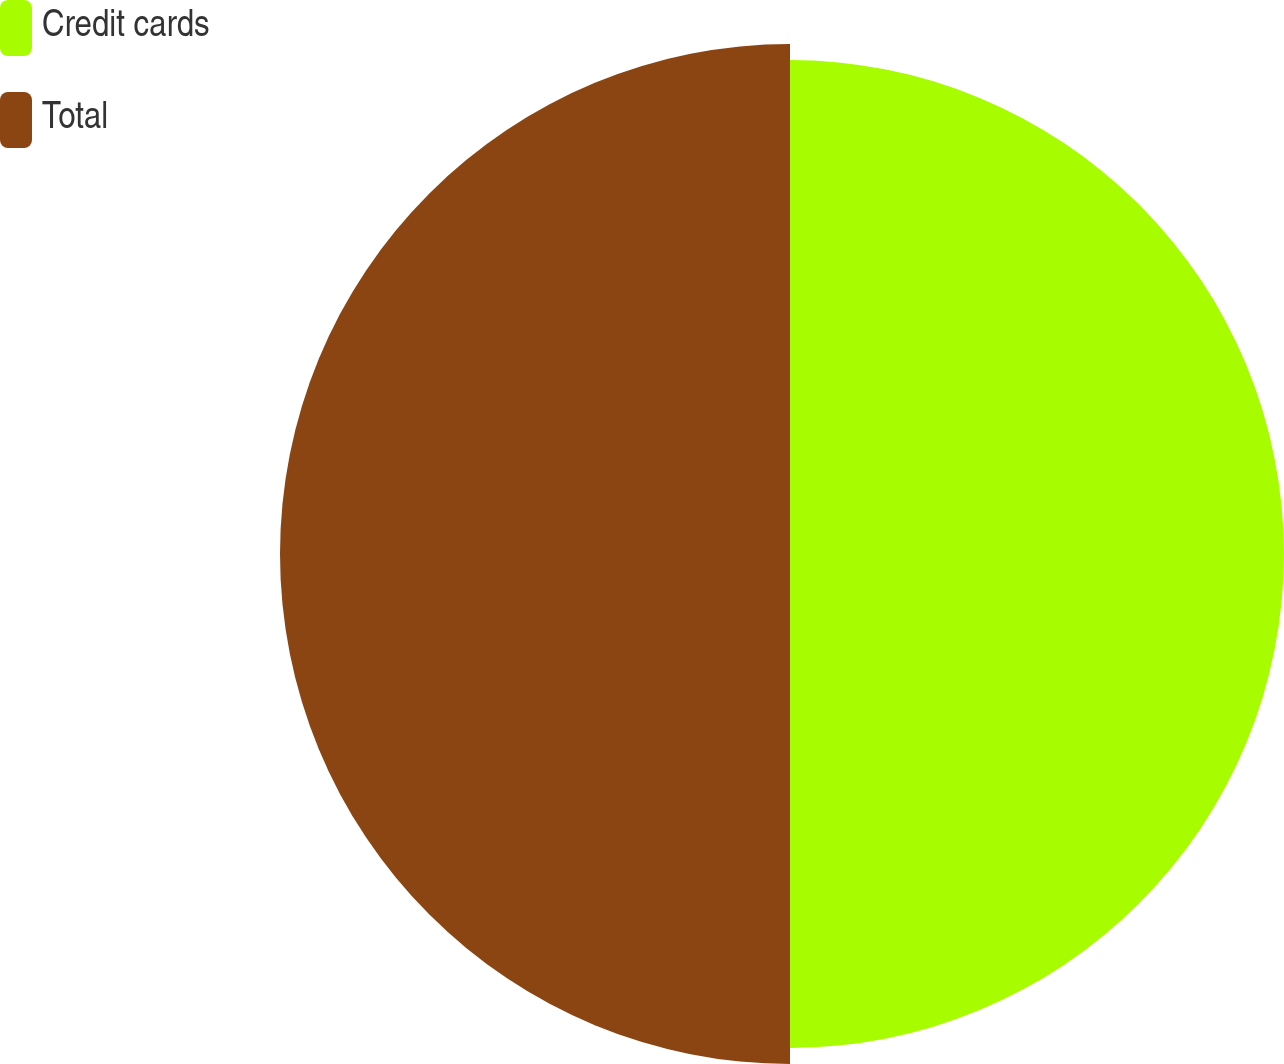<chart> <loc_0><loc_0><loc_500><loc_500><pie_chart><fcel>Credit cards<fcel>Total<nl><fcel>49.2%<fcel>50.8%<nl></chart> 